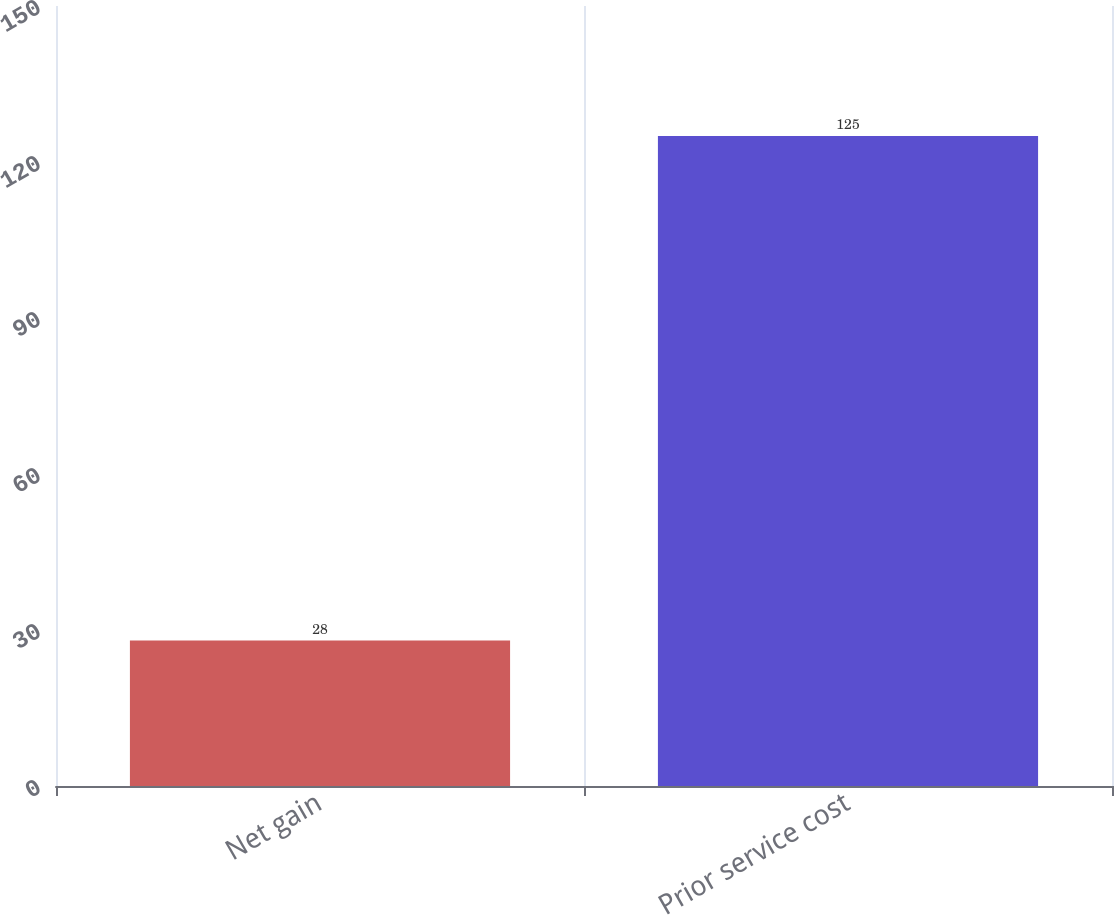Convert chart. <chart><loc_0><loc_0><loc_500><loc_500><bar_chart><fcel>Net gain<fcel>Prior service cost<nl><fcel>28<fcel>125<nl></chart> 